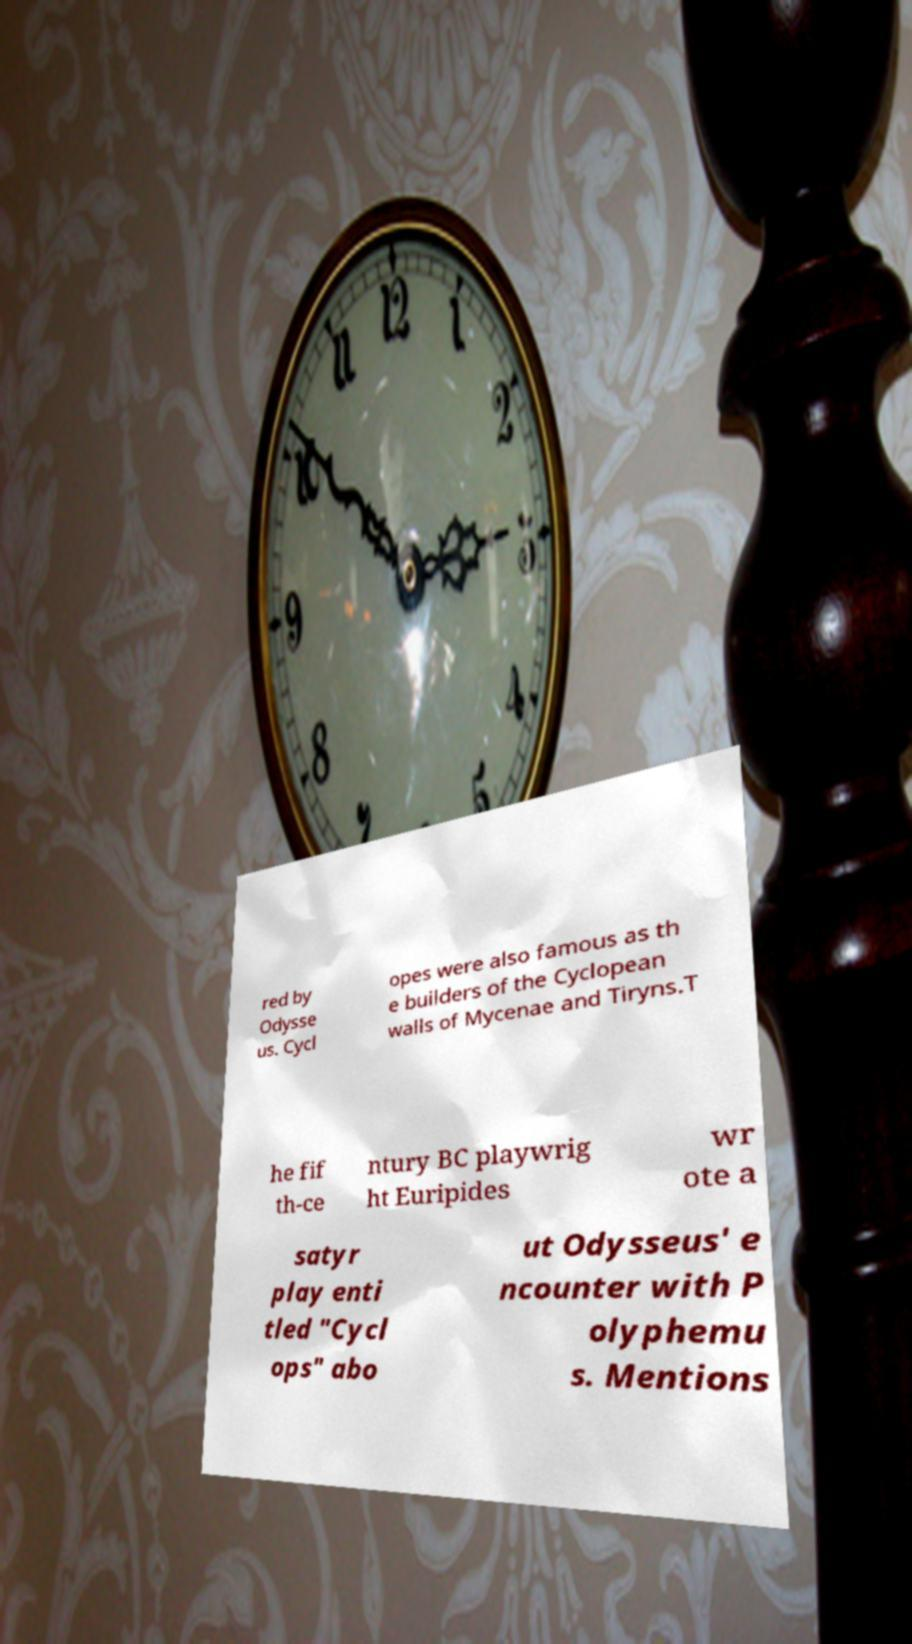I need the written content from this picture converted into text. Can you do that? red by Odysse us. Cycl opes were also famous as th e builders of the Cyclopean walls of Mycenae and Tiryns.T he fif th-ce ntury BC playwrig ht Euripides wr ote a satyr play enti tled "Cycl ops" abo ut Odysseus' e ncounter with P olyphemu s. Mentions 